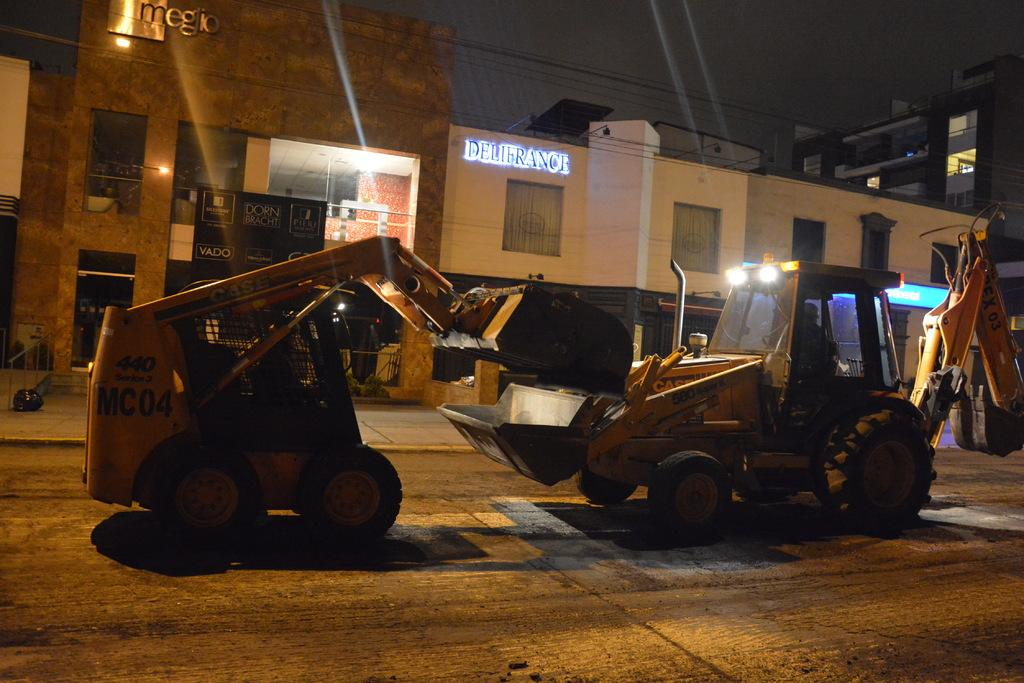<image>
Provide a brief description of the given image. the word deli france is above the street with many items 